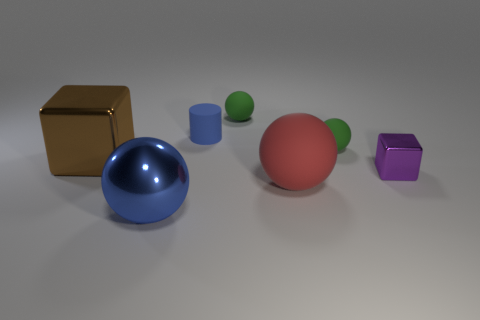The ball that is the same color as the small cylinder is what size?
Provide a succinct answer. Large. What is the material of the big ball that is the same color as the cylinder?
Keep it short and to the point. Metal. There is a matte thing in front of the big shiny cube; is its size the same as the blue object behind the metallic ball?
Give a very brief answer. No. How many balls are both in front of the cylinder and behind the purple cube?
Offer a terse response. 1. What color is the other small object that is the same shape as the brown thing?
Provide a short and direct response. Purple. Is the number of large brown shiny cubes less than the number of tiny red metallic spheres?
Your answer should be very brief. No. Is the size of the purple metallic cube the same as the red matte thing that is right of the tiny blue object?
Provide a short and direct response. No. There is a tiny matte ball to the left of the large sphere right of the blue rubber cylinder; what is its color?
Keep it short and to the point. Green. What number of things are either metal blocks that are right of the big matte ball or rubber objects in front of the big brown metal block?
Provide a succinct answer. 2. Do the blue sphere and the purple metal object have the same size?
Provide a succinct answer. No. 